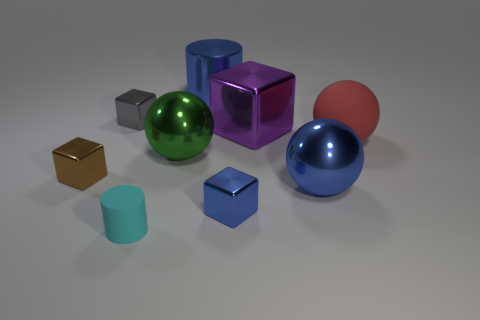Subtract all cubes. How many objects are left? 5 Subtract all cylinders. Subtract all large metallic cylinders. How many objects are left? 6 Add 7 big rubber spheres. How many big rubber spheres are left? 8 Add 3 blue blocks. How many blue blocks exist? 4 Subtract 1 cyan cylinders. How many objects are left? 8 